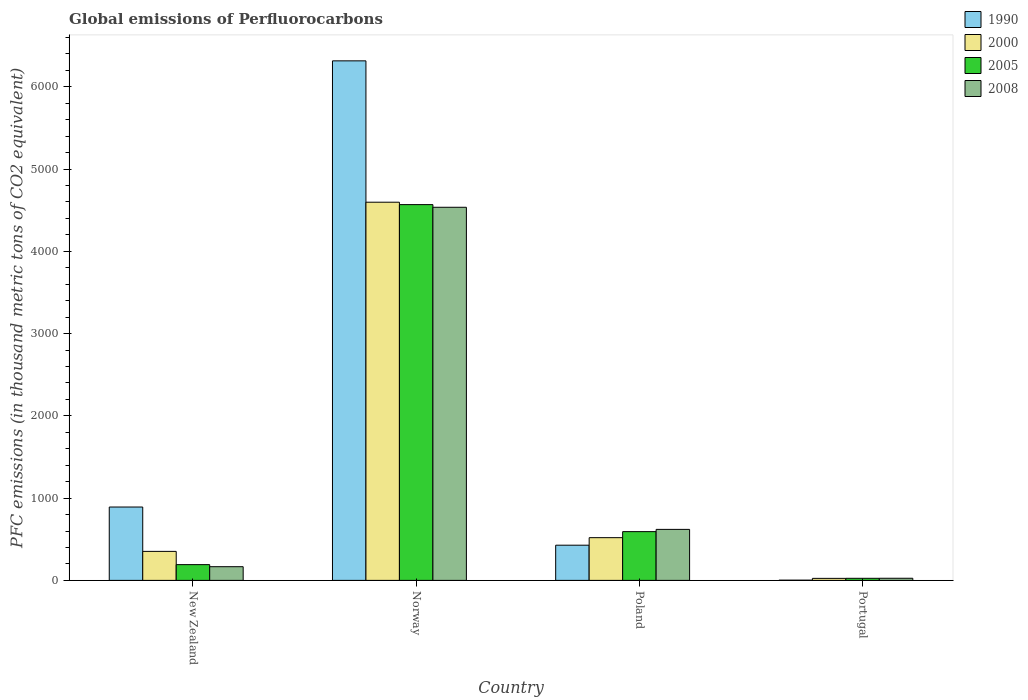Are the number of bars on each tick of the X-axis equal?
Give a very brief answer. Yes. What is the label of the 3rd group of bars from the left?
Ensure brevity in your answer.  Poland. What is the global emissions of Perfluorocarbons in 1990 in Portugal?
Ensure brevity in your answer.  2.6. Across all countries, what is the maximum global emissions of Perfluorocarbons in 2000?
Provide a short and direct response. 4597.3. Across all countries, what is the minimum global emissions of Perfluorocarbons in 2000?
Keep it short and to the point. 24.6. In which country was the global emissions of Perfluorocarbons in 1990 maximum?
Provide a succinct answer. Norway. In which country was the global emissions of Perfluorocarbons in 2005 minimum?
Provide a succinct answer. Portugal. What is the total global emissions of Perfluorocarbons in 2005 in the graph?
Provide a succinct answer. 5377.8. What is the difference between the global emissions of Perfluorocarbons in 2000 in New Zealand and that in Poland?
Give a very brief answer. -166.7. What is the difference between the global emissions of Perfluorocarbons in 2008 in Poland and the global emissions of Perfluorocarbons in 2005 in Portugal?
Provide a short and direct response. 594.7. What is the average global emissions of Perfluorocarbons in 2008 per country?
Make the answer very short. 1337.02. What is the difference between the global emissions of Perfluorocarbons of/in 2008 and global emissions of Perfluorocarbons of/in 1990 in Portugal?
Provide a succinct answer. 23.3. What is the ratio of the global emissions of Perfluorocarbons in 2005 in New Zealand to that in Norway?
Make the answer very short. 0.04. What is the difference between the highest and the second highest global emissions of Perfluorocarbons in 2000?
Provide a short and direct response. -4244.7. What is the difference between the highest and the lowest global emissions of Perfluorocarbons in 2005?
Provide a short and direct response. 4542.7. In how many countries, is the global emissions of Perfluorocarbons in 2005 greater than the average global emissions of Perfluorocarbons in 2005 taken over all countries?
Keep it short and to the point. 1. Is the sum of the global emissions of Perfluorocarbons in 2000 in New Zealand and Norway greater than the maximum global emissions of Perfluorocarbons in 1990 across all countries?
Your answer should be very brief. No. Is it the case that in every country, the sum of the global emissions of Perfluorocarbons in 2008 and global emissions of Perfluorocarbons in 2000 is greater than the sum of global emissions of Perfluorocarbons in 2005 and global emissions of Perfluorocarbons in 1990?
Keep it short and to the point. No. What does the 4th bar from the left in New Zealand represents?
Offer a terse response. 2008. How many bars are there?
Make the answer very short. 16. How many countries are there in the graph?
Provide a succinct answer. 4. What is the difference between two consecutive major ticks on the Y-axis?
Provide a short and direct response. 1000. Are the values on the major ticks of Y-axis written in scientific E-notation?
Provide a short and direct response. No. Where does the legend appear in the graph?
Offer a terse response. Top right. How are the legend labels stacked?
Give a very brief answer. Vertical. What is the title of the graph?
Give a very brief answer. Global emissions of Perfluorocarbons. What is the label or title of the Y-axis?
Ensure brevity in your answer.  PFC emissions (in thousand metric tons of CO2 equivalent). What is the PFC emissions (in thousand metric tons of CO2 equivalent) in 1990 in New Zealand?
Give a very brief answer. 891.8. What is the PFC emissions (in thousand metric tons of CO2 equivalent) in 2000 in New Zealand?
Provide a succinct answer. 352.6. What is the PFC emissions (in thousand metric tons of CO2 equivalent) of 2005 in New Zealand?
Your response must be concise. 191.6. What is the PFC emissions (in thousand metric tons of CO2 equivalent) in 2008 in New Zealand?
Offer a very short reply. 166.4. What is the PFC emissions (in thousand metric tons of CO2 equivalent) in 1990 in Norway?
Your answer should be very brief. 6315.7. What is the PFC emissions (in thousand metric tons of CO2 equivalent) of 2000 in Norway?
Keep it short and to the point. 4597.3. What is the PFC emissions (in thousand metric tons of CO2 equivalent) of 2005 in Norway?
Keep it short and to the point. 4568.1. What is the PFC emissions (in thousand metric tons of CO2 equivalent) in 2008 in Norway?
Offer a very short reply. 4535.7. What is the PFC emissions (in thousand metric tons of CO2 equivalent) of 1990 in Poland?
Your response must be concise. 427.8. What is the PFC emissions (in thousand metric tons of CO2 equivalent) of 2000 in Poland?
Keep it short and to the point. 519.3. What is the PFC emissions (in thousand metric tons of CO2 equivalent) in 2005 in Poland?
Offer a terse response. 592.7. What is the PFC emissions (in thousand metric tons of CO2 equivalent) of 2008 in Poland?
Your answer should be very brief. 620.1. What is the PFC emissions (in thousand metric tons of CO2 equivalent) in 1990 in Portugal?
Provide a succinct answer. 2.6. What is the PFC emissions (in thousand metric tons of CO2 equivalent) of 2000 in Portugal?
Your response must be concise. 24.6. What is the PFC emissions (in thousand metric tons of CO2 equivalent) of 2005 in Portugal?
Provide a short and direct response. 25.4. What is the PFC emissions (in thousand metric tons of CO2 equivalent) in 2008 in Portugal?
Keep it short and to the point. 25.9. Across all countries, what is the maximum PFC emissions (in thousand metric tons of CO2 equivalent) of 1990?
Ensure brevity in your answer.  6315.7. Across all countries, what is the maximum PFC emissions (in thousand metric tons of CO2 equivalent) in 2000?
Ensure brevity in your answer.  4597.3. Across all countries, what is the maximum PFC emissions (in thousand metric tons of CO2 equivalent) in 2005?
Offer a very short reply. 4568.1. Across all countries, what is the maximum PFC emissions (in thousand metric tons of CO2 equivalent) of 2008?
Offer a very short reply. 4535.7. Across all countries, what is the minimum PFC emissions (in thousand metric tons of CO2 equivalent) in 2000?
Your answer should be very brief. 24.6. Across all countries, what is the minimum PFC emissions (in thousand metric tons of CO2 equivalent) of 2005?
Your answer should be very brief. 25.4. Across all countries, what is the minimum PFC emissions (in thousand metric tons of CO2 equivalent) in 2008?
Your response must be concise. 25.9. What is the total PFC emissions (in thousand metric tons of CO2 equivalent) of 1990 in the graph?
Ensure brevity in your answer.  7637.9. What is the total PFC emissions (in thousand metric tons of CO2 equivalent) of 2000 in the graph?
Offer a very short reply. 5493.8. What is the total PFC emissions (in thousand metric tons of CO2 equivalent) in 2005 in the graph?
Offer a terse response. 5377.8. What is the total PFC emissions (in thousand metric tons of CO2 equivalent) in 2008 in the graph?
Your answer should be compact. 5348.1. What is the difference between the PFC emissions (in thousand metric tons of CO2 equivalent) in 1990 in New Zealand and that in Norway?
Offer a terse response. -5423.9. What is the difference between the PFC emissions (in thousand metric tons of CO2 equivalent) of 2000 in New Zealand and that in Norway?
Provide a succinct answer. -4244.7. What is the difference between the PFC emissions (in thousand metric tons of CO2 equivalent) in 2005 in New Zealand and that in Norway?
Ensure brevity in your answer.  -4376.5. What is the difference between the PFC emissions (in thousand metric tons of CO2 equivalent) in 2008 in New Zealand and that in Norway?
Make the answer very short. -4369.3. What is the difference between the PFC emissions (in thousand metric tons of CO2 equivalent) in 1990 in New Zealand and that in Poland?
Make the answer very short. 464. What is the difference between the PFC emissions (in thousand metric tons of CO2 equivalent) in 2000 in New Zealand and that in Poland?
Make the answer very short. -166.7. What is the difference between the PFC emissions (in thousand metric tons of CO2 equivalent) in 2005 in New Zealand and that in Poland?
Provide a short and direct response. -401.1. What is the difference between the PFC emissions (in thousand metric tons of CO2 equivalent) of 2008 in New Zealand and that in Poland?
Ensure brevity in your answer.  -453.7. What is the difference between the PFC emissions (in thousand metric tons of CO2 equivalent) in 1990 in New Zealand and that in Portugal?
Offer a very short reply. 889.2. What is the difference between the PFC emissions (in thousand metric tons of CO2 equivalent) in 2000 in New Zealand and that in Portugal?
Provide a succinct answer. 328. What is the difference between the PFC emissions (in thousand metric tons of CO2 equivalent) in 2005 in New Zealand and that in Portugal?
Offer a very short reply. 166.2. What is the difference between the PFC emissions (in thousand metric tons of CO2 equivalent) in 2008 in New Zealand and that in Portugal?
Make the answer very short. 140.5. What is the difference between the PFC emissions (in thousand metric tons of CO2 equivalent) of 1990 in Norway and that in Poland?
Offer a terse response. 5887.9. What is the difference between the PFC emissions (in thousand metric tons of CO2 equivalent) of 2000 in Norway and that in Poland?
Offer a terse response. 4078. What is the difference between the PFC emissions (in thousand metric tons of CO2 equivalent) of 2005 in Norway and that in Poland?
Your answer should be compact. 3975.4. What is the difference between the PFC emissions (in thousand metric tons of CO2 equivalent) of 2008 in Norway and that in Poland?
Your answer should be very brief. 3915.6. What is the difference between the PFC emissions (in thousand metric tons of CO2 equivalent) in 1990 in Norway and that in Portugal?
Your answer should be very brief. 6313.1. What is the difference between the PFC emissions (in thousand metric tons of CO2 equivalent) of 2000 in Norway and that in Portugal?
Your answer should be compact. 4572.7. What is the difference between the PFC emissions (in thousand metric tons of CO2 equivalent) in 2005 in Norway and that in Portugal?
Make the answer very short. 4542.7. What is the difference between the PFC emissions (in thousand metric tons of CO2 equivalent) in 2008 in Norway and that in Portugal?
Your answer should be compact. 4509.8. What is the difference between the PFC emissions (in thousand metric tons of CO2 equivalent) of 1990 in Poland and that in Portugal?
Offer a very short reply. 425.2. What is the difference between the PFC emissions (in thousand metric tons of CO2 equivalent) of 2000 in Poland and that in Portugal?
Your answer should be very brief. 494.7. What is the difference between the PFC emissions (in thousand metric tons of CO2 equivalent) in 2005 in Poland and that in Portugal?
Give a very brief answer. 567.3. What is the difference between the PFC emissions (in thousand metric tons of CO2 equivalent) of 2008 in Poland and that in Portugal?
Ensure brevity in your answer.  594.2. What is the difference between the PFC emissions (in thousand metric tons of CO2 equivalent) of 1990 in New Zealand and the PFC emissions (in thousand metric tons of CO2 equivalent) of 2000 in Norway?
Ensure brevity in your answer.  -3705.5. What is the difference between the PFC emissions (in thousand metric tons of CO2 equivalent) of 1990 in New Zealand and the PFC emissions (in thousand metric tons of CO2 equivalent) of 2005 in Norway?
Provide a short and direct response. -3676.3. What is the difference between the PFC emissions (in thousand metric tons of CO2 equivalent) in 1990 in New Zealand and the PFC emissions (in thousand metric tons of CO2 equivalent) in 2008 in Norway?
Give a very brief answer. -3643.9. What is the difference between the PFC emissions (in thousand metric tons of CO2 equivalent) of 2000 in New Zealand and the PFC emissions (in thousand metric tons of CO2 equivalent) of 2005 in Norway?
Your response must be concise. -4215.5. What is the difference between the PFC emissions (in thousand metric tons of CO2 equivalent) of 2000 in New Zealand and the PFC emissions (in thousand metric tons of CO2 equivalent) of 2008 in Norway?
Ensure brevity in your answer.  -4183.1. What is the difference between the PFC emissions (in thousand metric tons of CO2 equivalent) in 2005 in New Zealand and the PFC emissions (in thousand metric tons of CO2 equivalent) in 2008 in Norway?
Keep it short and to the point. -4344.1. What is the difference between the PFC emissions (in thousand metric tons of CO2 equivalent) in 1990 in New Zealand and the PFC emissions (in thousand metric tons of CO2 equivalent) in 2000 in Poland?
Make the answer very short. 372.5. What is the difference between the PFC emissions (in thousand metric tons of CO2 equivalent) in 1990 in New Zealand and the PFC emissions (in thousand metric tons of CO2 equivalent) in 2005 in Poland?
Offer a terse response. 299.1. What is the difference between the PFC emissions (in thousand metric tons of CO2 equivalent) in 1990 in New Zealand and the PFC emissions (in thousand metric tons of CO2 equivalent) in 2008 in Poland?
Offer a very short reply. 271.7. What is the difference between the PFC emissions (in thousand metric tons of CO2 equivalent) in 2000 in New Zealand and the PFC emissions (in thousand metric tons of CO2 equivalent) in 2005 in Poland?
Make the answer very short. -240.1. What is the difference between the PFC emissions (in thousand metric tons of CO2 equivalent) in 2000 in New Zealand and the PFC emissions (in thousand metric tons of CO2 equivalent) in 2008 in Poland?
Keep it short and to the point. -267.5. What is the difference between the PFC emissions (in thousand metric tons of CO2 equivalent) of 2005 in New Zealand and the PFC emissions (in thousand metric tons of CO2 equivalent) of 2008 in Poland?
Offer a very short reply. -428.5. What is the difference between the PFC emissions (in thousand metric tons of CO2 equivalent) in 1990 in New Zealand and the PFC emissions (in thousand metric tons of CO2 equivalent) in 2000 in Portugal?
Keep it short and to the point. 867.2. What is the difference between the PFC emissions (in thousand metric tons of CO2 equivalent) in 1990 in New Zealand and the PFC emissions (in thousand metric tons of CO2 equivalent) in 2005 in Portugal?
Provide a short and direct response. 866.4. What is the difference between the PFC emissions (in thousand metric tons of CO2 equivalent) of 1990 in New Zealand and the PFC emissions (in thousand metric tons of CO2 equivalent) of 2008 in Portugal?
Provide a succinct answer. 865.9. What is the difference between the PFC emissions (in thousand metric tons of CO2 equivalent) in 2000 in New Zealand and the PFC emissions (in thousand metric tons of CO2 equivalent) in 2005 in Portugal?
Your answer should be compact. 327.2. What is the difference between the PFC emissions (in thousand metric tons of CO2 equivalent) in 2000 in New Zealand and the PFC emissions (in thousand metric tons of CO2 equivalent) in 2008 in Portugal?
Your answer should be compact. 326.7. What is the difference between the PFC emissions (in thousand metric tons of CO2 equivalent) in 2005 in New Zealand and the PFC emissions (in thousand metric tons of CO2 equivalent) in 2008 in Portugal?
Give a very brief answer. 165.7. What is the difference between the PFC emissions (in thousand metric tons of CO2 equivalent) in 1990 in Norway and the PFC emissions (in thousand metric tons of CO2 equivalent) in 2000 in Poland?
Provide a succinct answer. 5796.4. What is the difference between the PFC emissions (in thousand metric tons of CO2 equivalent) in 1990 in Norway and the PFC emissions (in thousand metric tons of CO2 equivalent) in 2005 in Poland?
Provide a succinct answer. 5723. What is the difference between the PFC emissions (in thousand metric tons of CO2 equivalent) in 1990 in Norway and the PFC emissions (in thousand metric tons of CO2 equivalent) in 2008 in Poland?
Provide a short and direct response. 5695.6. What is the difference between the PFC emissions (in thousand metric tons of CO2 equivalent) of 2000 in Norway and the PFC emissions (in thousand metric tons of CO2 equivalent) of 2005 in Poland?
Offer a very short reply. 4004.6. What is the difference between the PFC emissions (in thousand metric tons of CO2 equivalent) in 2000 in Norway and the PFC emissions (in thousand metric tons of CO2 equivalent) in 2008 in Poland?
Your answer should be very brief. 3977.2. What is the difference between the PFC emissions (in thousand metric tons of CO2 equivalent) of 2005 in Norway and the PFC emissions (in thousand metric tons of CO2 equivalent) of 2008 in Poland?
Your answer should be compact. 3948. What is the difference between the PFC emissions (in thousand metric tons of CO2 equivalent) of 1990 in Norway and the PFC emissions (in thousand metric tons of CO2 equivalent) of 2000 in Portugal?
Your response must be concise. 6291.1. What is the difference between the PFC emissions (in thousand metric tons of CO2 equivalent) of 1990 in Norway and the PFC emissions (in thousand metric tons of CO2 equivalent) of 2005 in Portugal?
Ensure brevity in your answer.  6290.3. What is the difference between the PFC emissions (in thousand metric tons of CO2 equivalent) of 1990 in Norway and the PFC emissions (in thousand metric tons of CO2 equivalent) of 2008 in Portugal?
Ensure brevity in your answer.  6289.8. What is the difference between the PFC emissions (in thousand metric tons of CO2 equivalent) of 2000 in Norway and the PFC emissions (in thousand metric tons of CO2 equivalent) of 2005 in Portugal?
Your answer should be compact. 4571.9. What is the difference between the PFC emissions (in thousand metric tons of CO2 equivalent) of 2000 in Norway and the PFC emissions (in thousand metric tons of CO2 equivalent) of 2008 in Portugal?
Your answer should be compact. 4571.4. What is the difference between the PFC emissions (in thousand metric tons of CO2 equivalent) in 2005 in Norway and the PFC emissions (in thousand metric tons of CO2 equivalent) in 2008 in Portugal?
Make the answer very short. 4542.2. What is the difference between the PFC emissions (in thousand metric tons of CO2 equivalent) of 1990 in Poland and the PFC emissions (in thousand metric tons of CO2 equivalent) of 2000 in Portugal?
Offer a very short reply. 403.2. What is the difference between the PFC emissions (in thousand metric tons of CO2 equivalent) of 1990 in Poland and the PFC emissions (in thousand metric tons of CO2 equivalent) of 2005 in Portugal?
Provide a succinct answer. 402.4. What is the difference between the PFC emissions (in thousand metric tons of CO2 equivalent) of 1990 in Poland and the PFC emissions (in thousand metric tons of CO2 equivalent) of 2008 in Portugal?
Give a very brief answer. 401.9. What is the difference between the PFC emissions (in thousand metric tons of CO2 equivalent) in 2000 in Poland and the PFC emissions (in thousand metric tons of CO2 equivalent) in 2005 in Portugal?
Give a very brief answer. 493.9. What is the difference between the PFC emissions (in thousand metric tons of CO2 equivalent) in 2000 in Poland and the PFC emissions (in thousand metric tons of CO2 equivalent) in 2008 in Portugal?
Offer a very short reply. 493.4. What is the difference between the PFC emissions (in thousand metric tons of CO2 equivalent) in 2005 in Poland and the PFC emissions (in thousand metric tons of CO2 equivalent) in 2008 in Portugal?
Your response must be concise. 566.8. What is the average PFC emissions (in thousand metric tons of CO2 equivalent) of 1990 per country?
Your answer should be compact. 1909.47. What is the average PFC emissions (in thousand metric tons of CO2 equivalent) in 2000 per country?
Your response must be concise. 1373.45. What is the average PFC emissions (in thousand metric tons of CO2 equivalent) of 2005 per country?
Offer a terse response. 1344.45. What is the average PFC emissions (in thousand metric tons of CO2 equivalent) of 2008 per country?
Offer a terse response. 1337.03. What is the difference between the PFC emissions (in thousand metric tons of CO2 equivalent) in 1990 and PFC emissions (in thousand metric tons of CO2 equivalent) in 2000 in New Zealand?
Your answer should be compact. 539.2. What is the difference between the PFC emissions (in thousand metric tons of CO2 equivalent) in 1990 and PFC emissions (in thousand metric tons of CO2 equivalent) in 2005 in New Zealand?
Your answer should be very brief. 700.2. What is the difference between the PFC emissions (in thousand metric tons of CO2 equivalent) of 1990 and PFC emissions (in thousand metric tons of CO2 equivalent) of 2008 in New Zealand?
Your answer should be compact. 725.4. What is the difference between the PFC emissions (in thousand metric tons of CO2 equivalent) of 2000 and PFC emissions (in thousand metric tons of CO2 equivalent) of 2005 in New Zealand?
Make the answer very short. 161. What is the difference between the PFC emissions (in thousand metric tons of CO2 equivalent) of 2000 and PFC emissions (in thousand metric tons of CO2 equivalent) of 2008 in New Zealand?
Your answer should be very brief. 186.2. What is the difference between the PFC emissions (in thousand metric tons of CO2 equivalent) of 2005 and PFC emissions (in thousand metric tons of CO2 equivalent) of 2008 in New Zealand?
Keep it short and to the point. 25.2. What is the difference between the PFC emissions (in thousand metric tons of CO2 equivalent) in 1990 and PFC emissions (in thousand metric tons of CO2 equivalent) in 2000 in Norway?
Give a very brief answer. 1718.4. What is the difference between the PFC emissions (in thousand metric tons of CO2 equivalent) of 1990 and PFC emissions (in thousand metric tons of CO2 equivalent) of 2005 in Norway?
Make the answer very short. 1747.6. What is the difference between the PFC emissions (in thousand metric tons of CO2 equivalent) of 1990 and PFC emissions (in thousand metric tons of CO2 equivalent) of 2008 in Norway?
Give a very brief answer. 1780. What is the difference between the PFC emissions (in thousand metric tons of CO2 equivalent) in 2000 and PFC emissions (in thousand metric tons of CO2 equivalent) in 2005 in Norway?
Give a very brief answer. 29.2. What is the difference between the PFC emissions (in thousand metric tons of CO2 equivalent) of 2000 and PFC emissions (in thousand metric tons of CO2 equivalent) of 2008 in Norway?
Provide a succinct answer. 61.6. What is the difference between the PFC emissions (in thousand metric tons of CO2 equivalent) in 2005 and PFC emissions (in thousand metric tons of CO2 equivalent) in 2008 in Norway?
Your response must be concise. 32.4. What is the difference between the PFC emissions (in thousand metric tons of CO2 equivalent) in 1990 and PFC emissions (in thousand metric tons of CO2 equivalent) in 2000 in Poland?
Provide a succinct answer. -91.5. What is the difference between the PFC emissions (in thousand metric tons of CO2 equivalent) in 1990 and PFC emissions (in thousand metric tons of CO2 equivalent) in 2005 in Poland?
Provide a short and direct response. -164.9. What is the difference between the PFC emissions (in thousand metric tons of CO2 equivalent) in 1990 and PFC emissions (in thousand metric tons of CO2 equivalent) in 2008 in Poland?
Make the answer very short. -192.3. What is the difference between the PFC emissions (in thousand metric tons of CO2 equivalent) of 2000 and PFC emissions (in thousand metric tons of CO2 equivalent) of 2005 in Poland?
Make the answer very short. -73.4. What is the difference between the PFC emissions (in thousand metric tons of CO2 equivalent) in 2000 and PFC emissions (in thousand metric tons of CO2 equivalent) in 2008 in Poland?
Offer a very short reply. -100.8. What is the difference between the PFC emissions (in thousand metric tons of CO2 equivalent) in 2005 and PFC emissions (in thousand metric tons of CO2 equivalent) in 2008 in Poland?
Your response must be concise. -27.4. What is the difference between the PFC emissions (in thousand metric tons of CO2 equivalent) of 1990 and PFC emissions (in thousand metric tons of CO2 equivalent) of 2000 in Portugal?
Give a very brief answer. -22. What is the difference between the PFC emissions (in thousand metric tons of CO2 equivalent) in 1990 and PFC emissions (in thousand metric tons of CO2 equivalent) in 2005 in Portugal?
Keep it short and to the point. -22.8. What is the difference between the PFC emissions (in thousand metric tons of CO2 equivalent) of 1990 and PFC emissions (in thousand metric tons of CO2 equivalent) of 2008 in Portugal?
Your answer should be compact. -23.3. What is the difference between the PFC emissions (in thousand metric tons of CO2 equivalent) in 2000 and PFC emissions (in thousand metric tons of CO2 equivalent) in 2008 in Portugal?
Provide a succinct answer. -1.3. What is the difference between the PFC emissions (in thousand metric tons of CO2 equivalent) in 2005 and PFC emissions (in thousand metric tons of CO2 equivalent) in 2008 in Portugal?
Your answer should be compact. -0.5. What is the ratio of the PFC emissions (in thousand metric tons of CO2 equivalent) of 1990 in New Zealand to that in Norway?
Offer a very short reply. 0.14. What is the ratio of the PFC emissions (in thousand metric tons of CO2 equivalent) of 2000 in New Zealand to that in Norway?
Offer a terse response. 0.08. What is the ratio of the PFC emissions (in thousand metric tons of CO2 equivalent) of 2005 in New Zealand to that in Norway?
Make the answer very short. 0.04. What is the ratio of the PFC emissions (in thousand metric tons of CO2 equivalent) in 2008 in New Zealand to that in Norway?
Provide a short and direct response. 0.04. What is the ratio of the PFC emissions (in thousand metric tons of CO2 equivalent) in 1990 in New Zealand to that in Poland?
Provide a succinct answer. 2.08. What is the ratio of the PFC emissions (in thousand metric tons of CO2 equivalent) of 2000 in New Zealand to that in Poland?
Your answer should be very brief. 0.68. What is the ratio of the PFC emissions (in thousand metric tons of CO2 equivalent) in 2005 in New Zealand to that in Poland?
Make the answer very short. 0.32. What is the ratio of the PFC emissions (in thousand metric tons of CO2 equivalent) in 2008 in New Zealand to that in Poland?
Give a very brief answer. 0.27. What is the ratio of the PFC emissions (in thousand metric tons of CO2 equivalent) in 1990 in New Zealand to that in Portugal?
Ensure brevity in your answer.  343. What is the ratio of the PFC emissions (in thousand metric tons of CO2 equivalent) in 2000 in New Zealand to that in Portugal?
Provide a succinct answer. 14.33. What is the ratio of the PFC emissions (in thousand metric tons of CO2 equivalent) of 2005 in New Zealand to that in Portugal?
Offer a terse response. 7.54. What is the ratio of the PFC emissions (in thousand metric tons of CO2 equivalent) of 2008 in New Zealand to that in Portugal?
Your response must be concise. 6.42. What is the ratio of the PFC emissions (in thousand metric tons of CO2 equivalent) in 1990 in Norway to that in Poland?
Keep it short and to the point. 14.76. What is the ratio of the PFC emissions (in thousand metric tons of CO2 equivalent) in 2000 in Norway to that in Poland?
Ensure brevity in your answer.  8.85. What is the ratio of the PFC emissions (in thousand metric tons of CO2 equivalent) of 2005 in Norway to that in Poland?
Your answer should be compact. 7.71. What is the ratio of the PFC emissions (in thousand metric tons of CO2 equivalent) of 2008 in Norway to that in Poland?
Ensure brevity in your answer.  7.31. What is the ratio of the PFC emissions (in thousand metric tons of CO2 equivalent) of 1990 in Norway to that in Portugal?
Ensure brevity in your answer.  2429.12. What is the ratio of the PFC emissions (in thousand metric tons of CO2 equivalent) in 2000 in Norway to that in Portugal?
Your answer should be compact. 186.88. What is the ratio of the PFC emissions (in thousand metric tons of CO2 equivalent) in 2005 in Norway to that in Portugal?
Your response must be concise. 179.85. What is the ratio of the PFC emissions (in thousand metric tons of CO2 equivalent) in 2008 in Norway to that in Portugal?
Provide a short and direct response. 175.12. What is the ratio of the PFC emissions (in thousand metric tons of CO2 equivalent) in 1990 in Poland to that in Portugal?
Give a very brief answer. 164.54. What is the ratio of the PFC emissions (in thousand metric tons of CO2 equivalent) of 2000 in Poland to that in Portugal?
Offer a very short reply. 21.11. What is the ratio of the PFC emissions (in thousand metric tons of CO2 equivalent) of 2005 in Poland to that in Portugal?
Ensure brevity in your answer.  23.33. What is the ratio of the PFC emissions (in thousand metric tons of CO2 equivalent) in 2008 in Poland to that in Portugal?
Offer a very short reply. 23.94. What is the difference between the highest and the second highest PFC emissions (in thousand metric tons of CO2 equivalent) of 1990?
Your answer should be compact. 5423.9. What is the difference between the highest and the second highest PFC emissions (in thousand metric tons of CO2 equivalent) in 2000?
Your response must be concise. 4078. What is the difference between the highest and the second highest PFC emissions (in thousand metric tons of CO2 equivalent) in 2005?
Your answer should be very brief. 3975.4. What is the difference between the highest and the second highest PFC emissions (in thousand metric tons of CO2 equivalent) of 2008?
Give a very brief answer. 3915.6. What is the difference between the highest and the lowest PFC emissions (in thousand metric tons of CO2 equivalent) in 1990?
Offer a terse response. 6313.1. What is the difference between the highest and the lowest PFC emissions (in thousand metric tons of CO2 equivalent) in 2000?
Your response must be concise. 4572.7. What is the difference between the highest and the lowest PFC emissions (in thousand metric tons of CO2 equivalent) of 2005?
Keep it short and to the point. 4542.7. What is the difference between the highest and the lowest PFC emissions (in thousand metric tons of CO2 equivalent) of 2008?
Offer a terse response. 4509.8. 